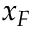Convert formula to latex. <formula><loc_0><loc_0><loc_500><loc_500>x _ { F }</formula> 